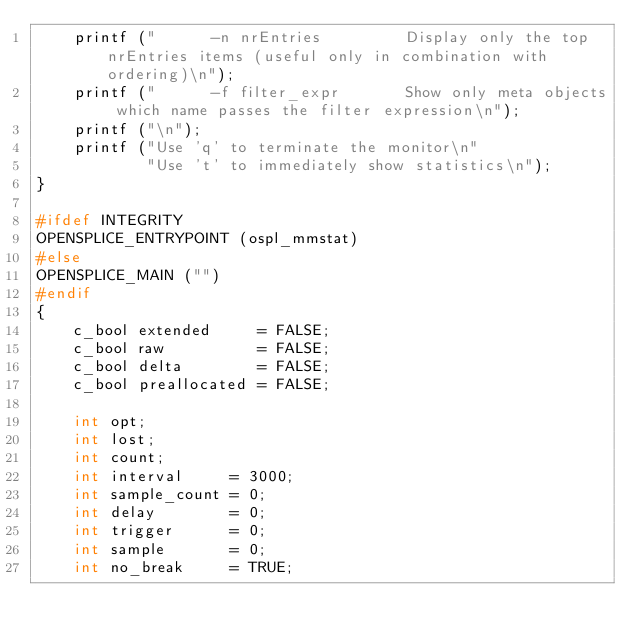Convert code to text. <code><loc_0><loc_0><loc_500><loc_500><_C_>    printf ("      -n nrEntries         Display only the top nrEntries items (useful only in combination with ordering)\n");
    printf ("      -f filter_expr       Show only meta objects which name passes the filter expression\n");
    printf ("\n");
    printf ("Use 'q' to terminate the monitor\n"
            "Use 't' to immediately show statistics\n");
}

#ifdef INTEGRITY
OPENSPLICE_ENTRYPOINT (ospl_mmstat)
#else
OPENSPLICE_MAIN ("")
#endif
{
    c_bool extended     = FALSE;
    c_bool raw          = FALSE;
    c_bool delta        = FALSE;
    c_bool preallocated = FALSE;

    int opt;
    int lost;
    int count;
    int interval     = 3000;
    int sample_count = 0;
    int delay        = 0;
    int trigger      = 0;
    int sample       = 0;
    int no_break     = TRUE;
</code> 